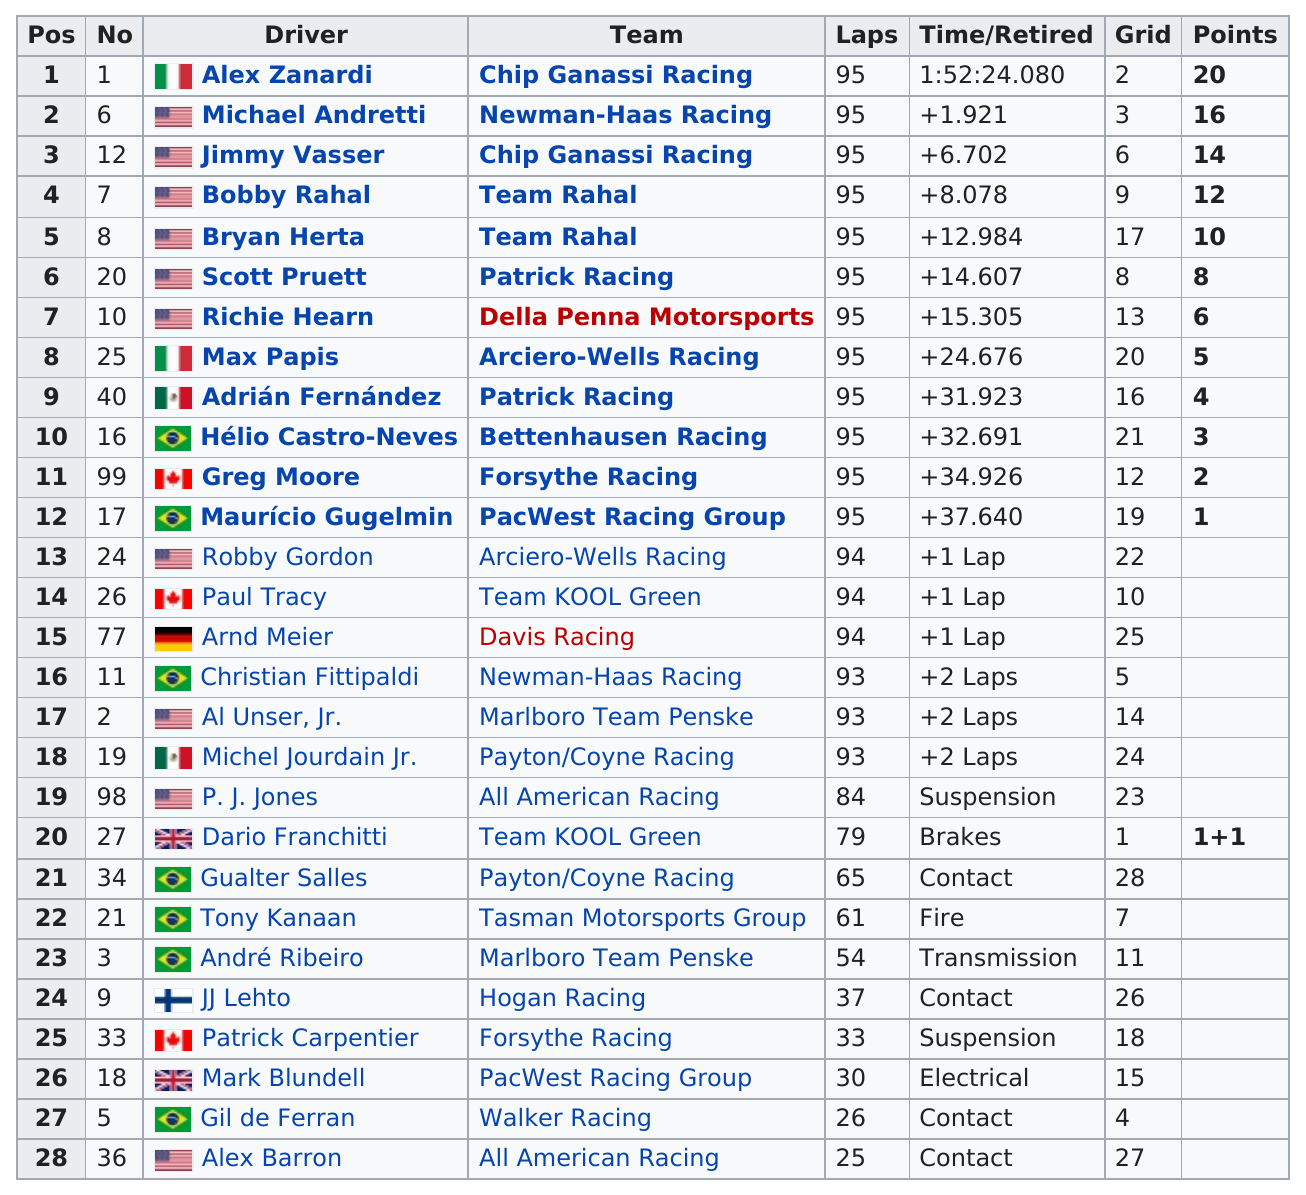List a handful of essential elements in this visual. Team Rahal had two drivers in the race. The team that is listed first on this chart is Chip Ganassi Racing. What was Richie Hearn's race position? Seventh. Alex Barron came in last place in the race, while Gil de Ferran finished ahead of him. Did Robby Gordon place above or below Bobby Rahal? 